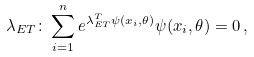Convert formula to latex. <formula><loc_0><loc_0><loc_500><loc_500>\lambda _ { E T } \colon \sum _ { i = 1 } ^ { n } e ^ { \lambda ^ { T } _ { E T } \psi ( x _ { i } , \theta ) } \psi ( x _ { i } , \theta ) = 0 \, ,</formula> 